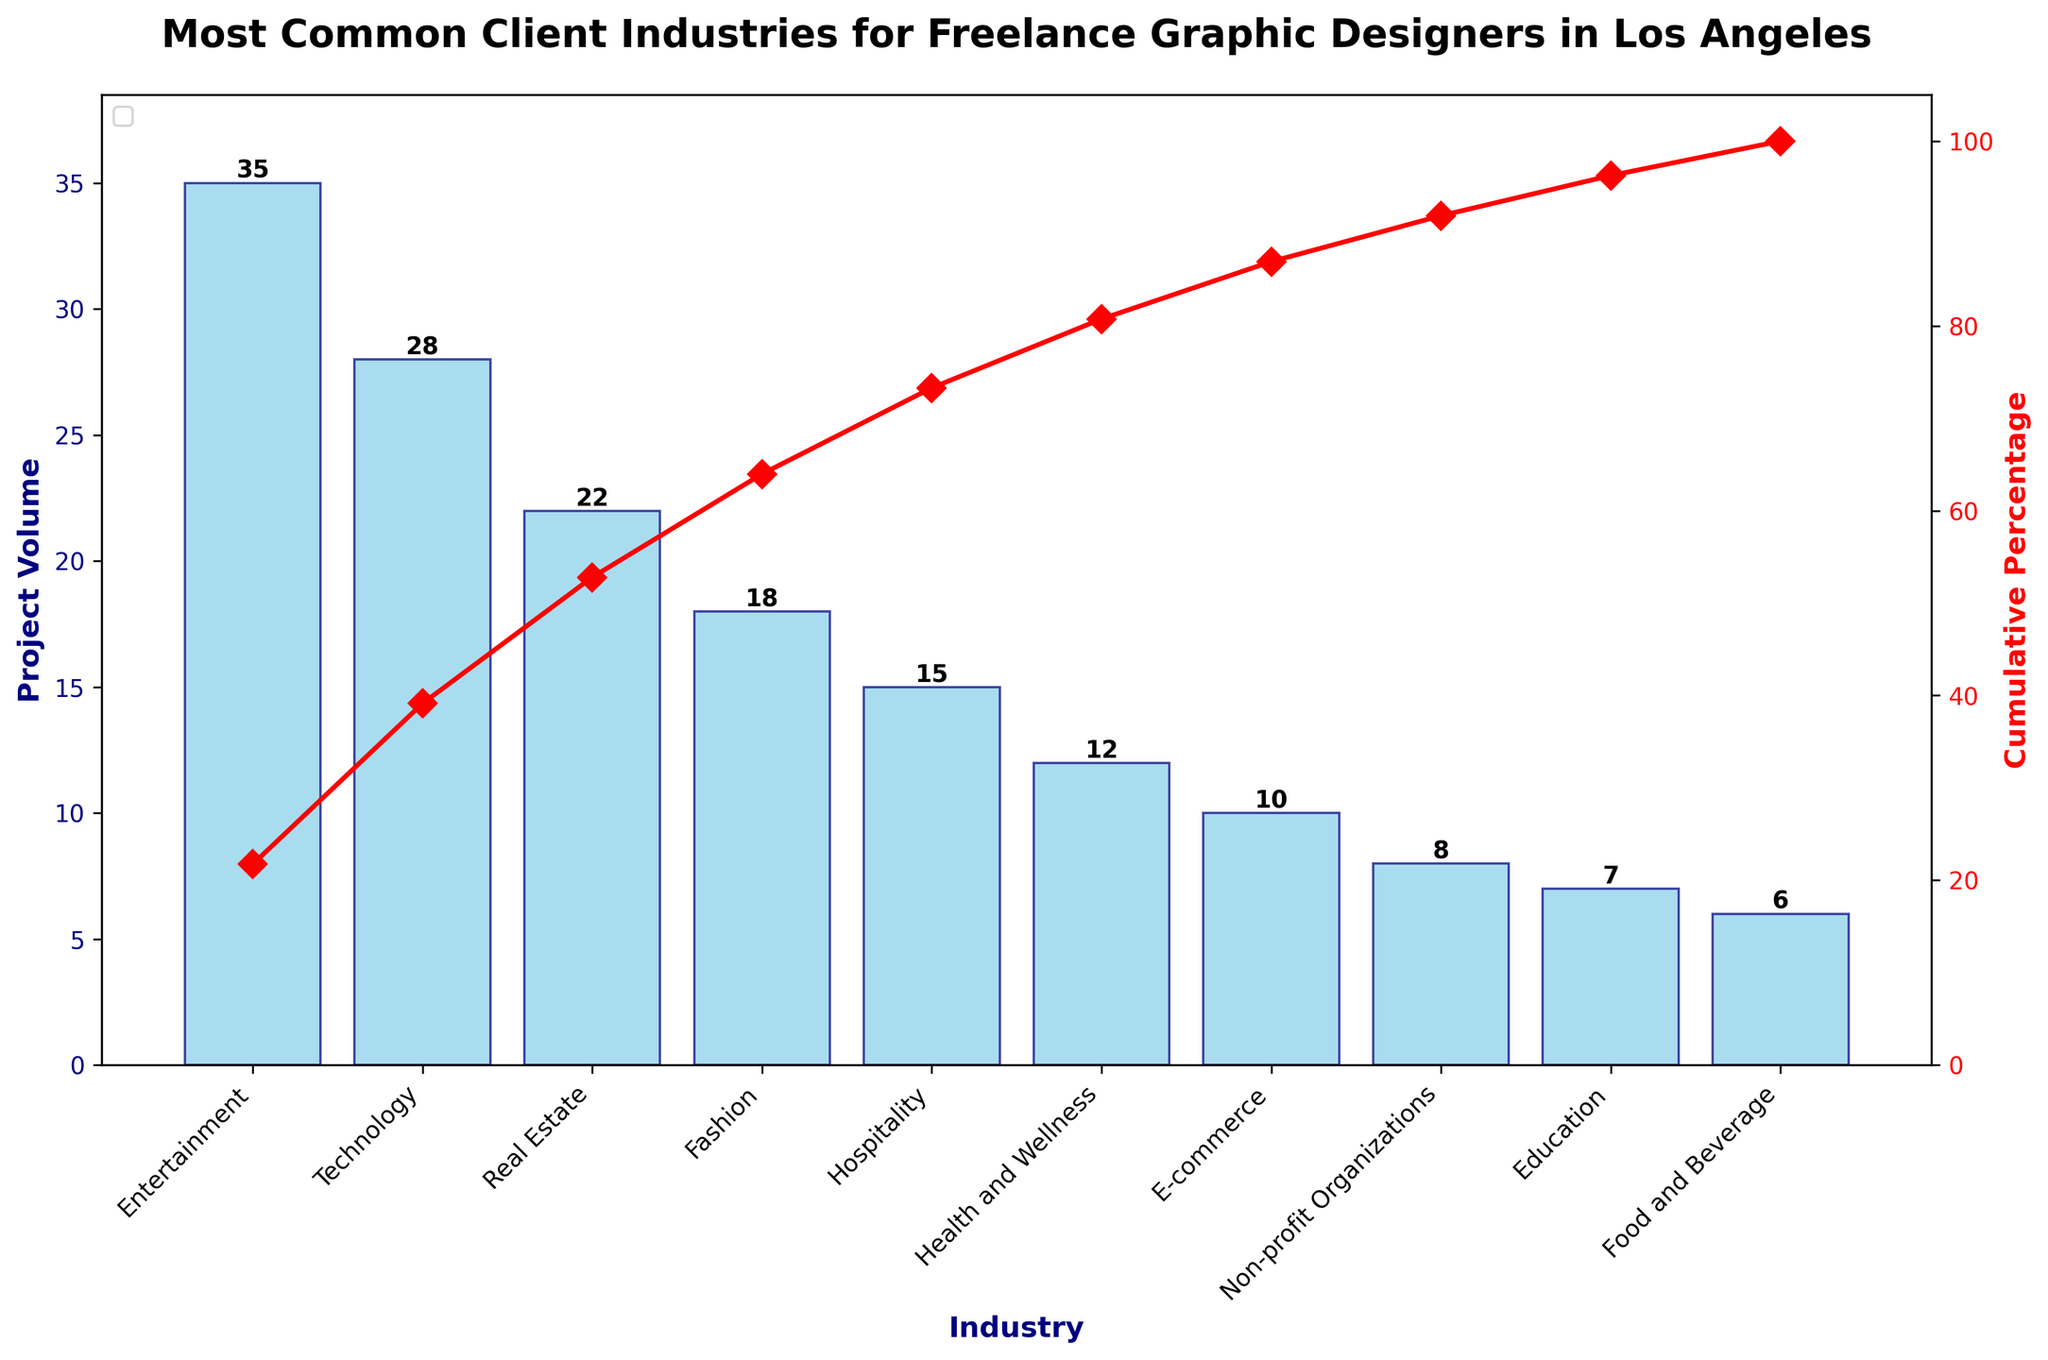What's the most common client industry for freelance graphic designers in Los Angeles by project volume? The most common industry is depicted by the tallest bar in the chart. In this case, "Entertainment" has the highest project volume at 35.
Answer: Entertainment Which two industries have the lowest project volume for freelance graphic designers in Los Angeles? The two shortest bars on the Pareto chart represent the industries with the lowest project volumes: "Food and Beverage" with 6 projects and "Education" with 7 projects.
Answer: Food and Beverage, Education How much higher is the project volume for the Entertainment industry compared to the Health and Wellness industry? The number of projects for Entertainment is 35 and for Health and Wellness is 12. The difference is 35 - 12 = 23.
Answer: 23 What is the cumulative percentage of the top three industries combined? Add the cumulative percentages of the top three industries: Entertainment (35/161*100), Technology (35+28/161*100), and Real Estate (35+28+22/161*100). Calculating these values: 21.7% + 39.8% + 53.4% = 53.4%.
Answer: 53.4% Which industry just crosses the 50% cumulative percentage mark? The cumulative percentage line on the chart shows that Real Estate crosses the 50% line.
Answer: Real Estate What is the difference in project volume between the Technology and Fashion industries? The project volume for Technology is 28 and for Fashion is 18. The difference is 28 - 18 = 10.
Answer: 10 What percentage of the total projects is accounted for by the top 5 industries? Sum the project volumes of the top 5 industries (35 + 28 + 22 + 18 + 15 = 118), divide by the total number of projects (161), and multiply by 100 to get the percentage: (118/161) * 100 = 73.3%.
Answer: 73.3% If you combine the project volumes of the Hospitality and Health and Wellness industries, how does it compare to the Technology industry's project volume? The combined project volume of Hospitality (15) and Health and Wellness (12) is 15 + 12 = 27, which is 1 less than the Technology industry's 28 projects.
Answer: 1 less Does the cumulative percentage reach 100% at the last industry? Yes, by definition of cumulative percentage, summing all industries' project volumes leads to 100% at the last industry.
Answer: Yes 